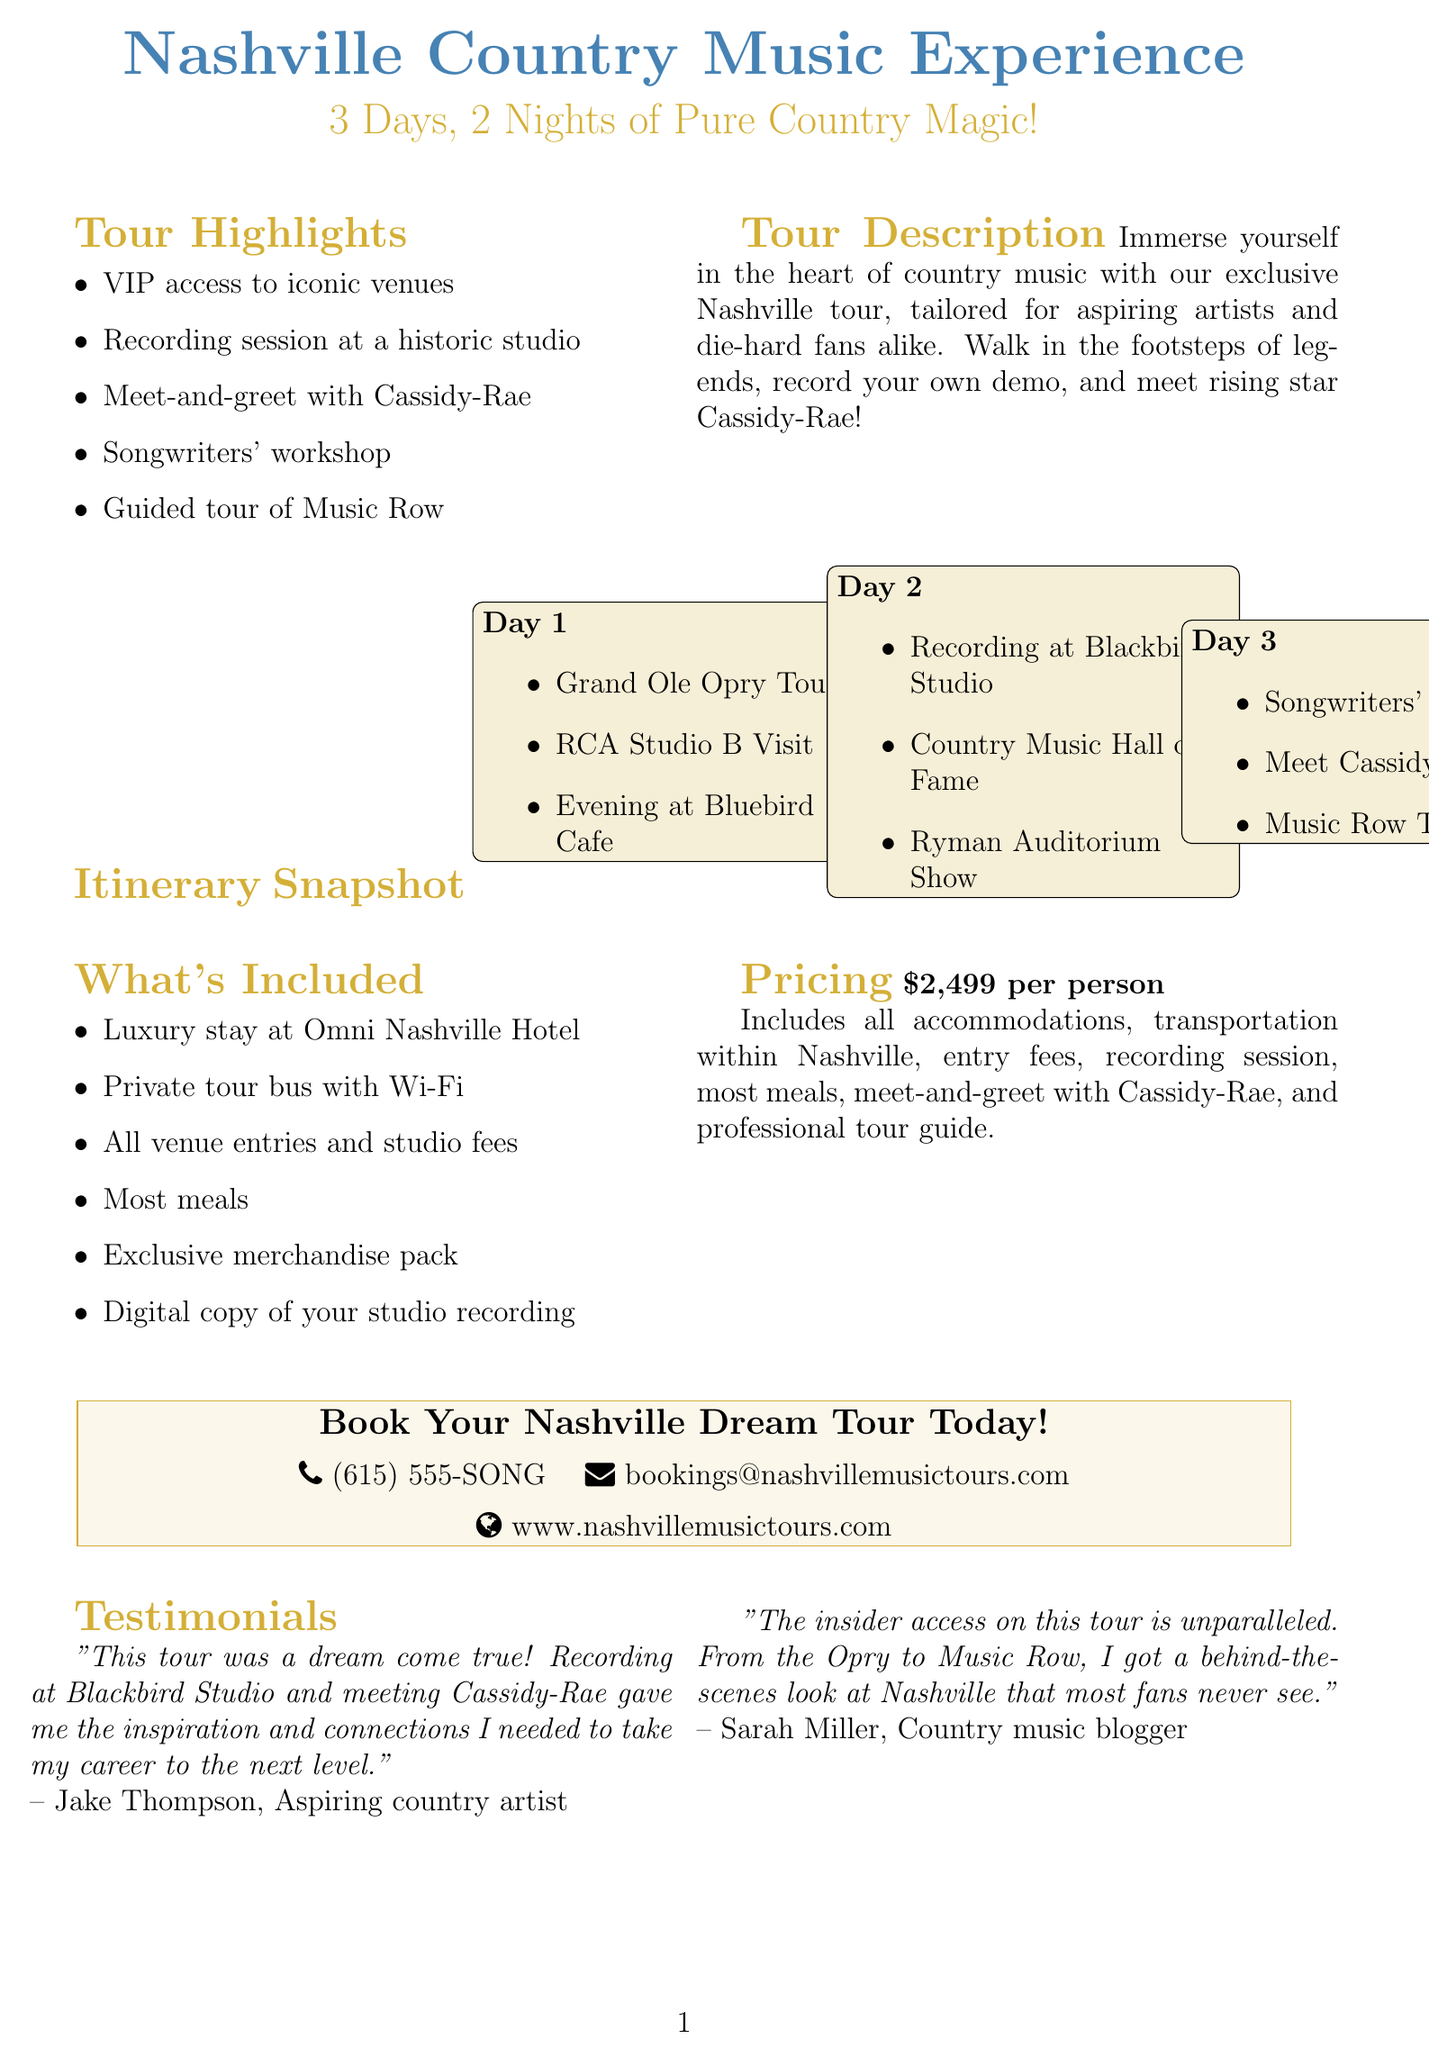what is the duration of the tour? The duration of the tour is specified in the document as "3 days, 2 nights."
Answer: 3 days, 2 nights who is the featured rising star in the tour? The document highlights Cassidy-Rae as a rising star participating in the tour.
Answer: Cassidy-Rae what venue do participants visit on Day 1 for an intimate songwriter's night? According to the itinerary, participants experience an evening at the Bluebird Cafe on Day 1.
Answer: Bluebird Cafe how much does the tour cost per person? The document states that the cost of the tour is "2,499 dollars" per person.
Answer: 2,499 dollars what type of workshop is included on Day 3? The itinerary includes a "Songwriters' Workshop" on Day 3.
Answer: Songwriters' Workshop what is included in the tour regarding meals? The document mentions that "most meals" are included in the pricing details.
Answer: most meals who taught the Songwriters' Workshop? The document indicates that the workshop is taught by hit songwriter Brett James.
Answer: Brett James where will the farewell dinner take place? According to the itinerary, the farewell dinner will be held at The Listening Room Cafe.
Answer: The Listening Room Cafe what type of transportation is provided during the tour? The document specifies that a "private tour bus with onboard Wi-Fi and charging stations" is provided for transportation.
Answer: private tour bus with onboard Wi-Fi and charging stations 